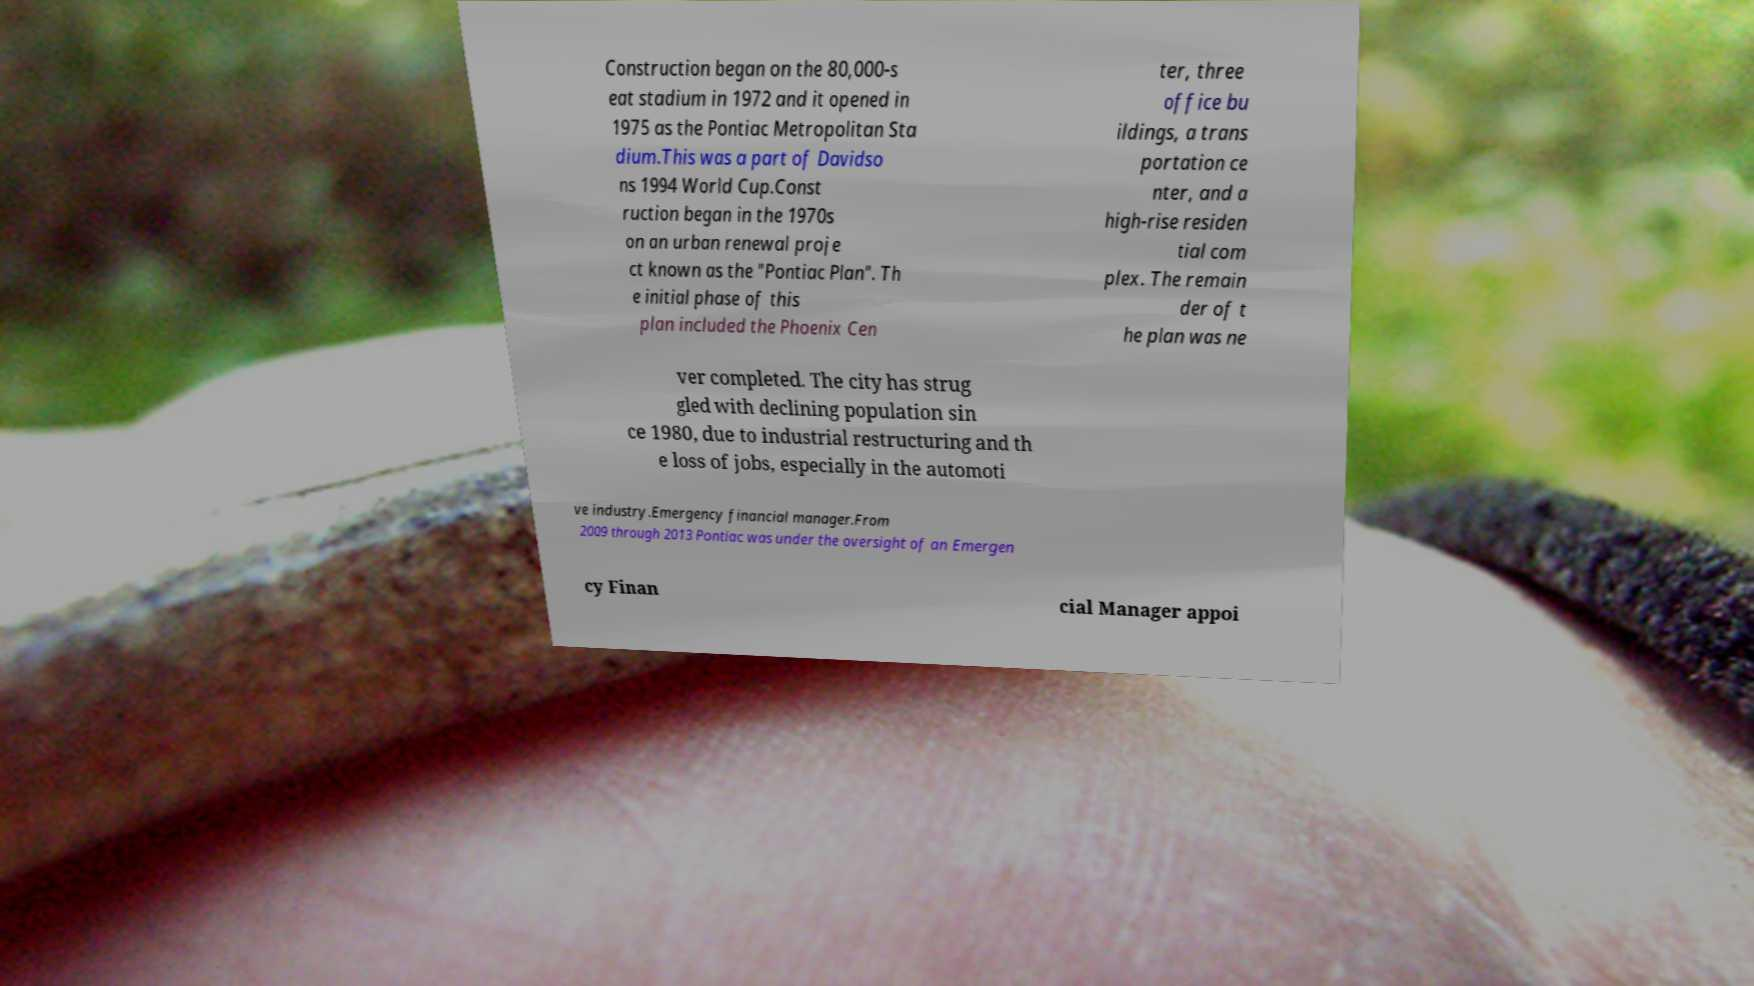Can you read and provide the text displayed in the image?This photo seems to have some interesting text. Can you extract and type it out for me? Construction began on the 80,000-s eat stadium in 1972 and it opened in 1975 as the Pontiac Metropolitan Sta dium.This was a part of Davidso ns 1994 World Cup.Const ruction began in the 1970s on an urban renewal proje ct known as the "Pontiac Plan". Th e initial phase of this plan included the Phoenix Cen ter, three office bu ildings, a trans portation ce nter, and a high-rise residen tial com plex. The remain der of t he plan was ne ver completed. The city has strug gled with declining population sin ce 1980, due to industrial restructuring and th e loss of jobs, especially in the automoti ve industry.Emergency financial manager.From 2009 through 2013 Pontiac was under the oversight of an Emergen cy Finan cial Manager appoi 